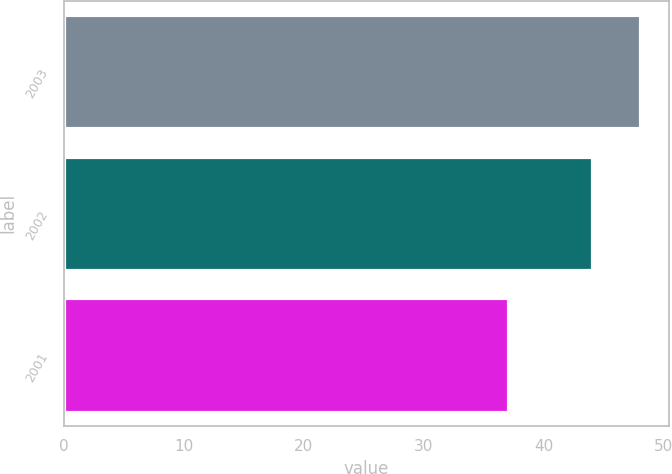Convert chart to OTSL. <chart><loc_0><loc_0><loc_500><loc_500><bar_chart><fcel>2003<fcel>2002<fcel>2001<nl><fcel>48<fcel>44<fcel>37<nl></chart> 